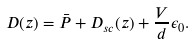Convert formula to latex. <formula><loc_0><loc_0><loc_500><loc_500>D ( z ) = \bar { P } + D _ { s c } ( z ) + \frac { V } { d } \epsilon _ { 0 } .</formula> 